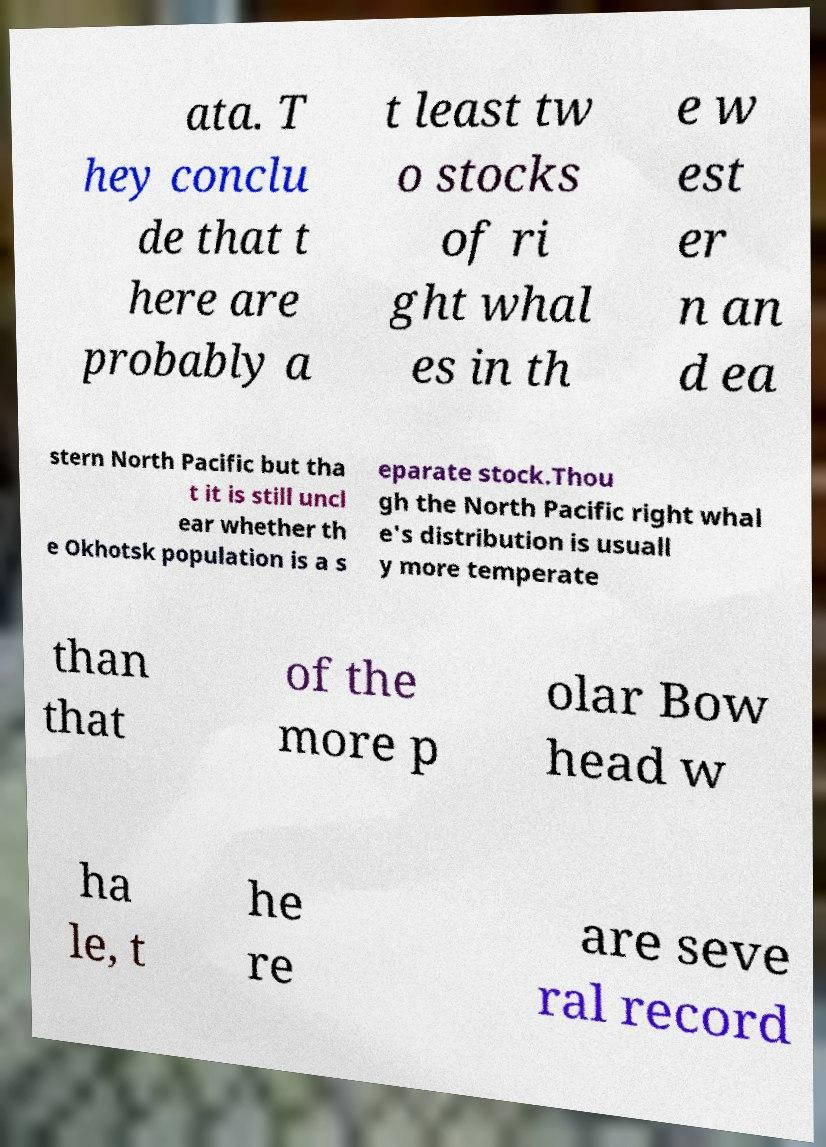Could you assist in decoding the text presented in this image and type it out clearly? ata. T hey conclu de that t here are probably a t least tw o stocks of ri ght whal es in th e w est er n an d ea stern North Pacific but tha t it is still uncl ear whether th e Okhotsk population is a s eparate stock.Thou gh the North Pacific right whal e's distribution is usuall y more temperate than that of the more p olar Bow head w ha le, t he re are seve ral record 